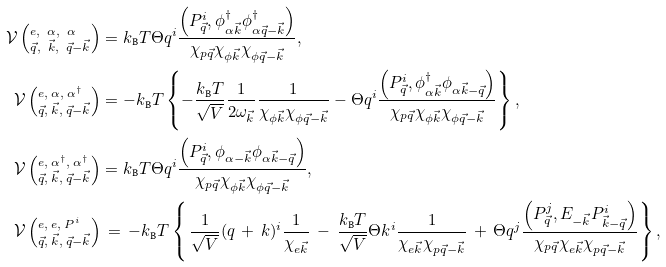<formula> <loc_0><loc_0><loc_500><loc_500>\mathcal { V } \left ( _ { \vec { q } , \ \vec { k } , \ \vec { q } - \vec { k } } ^ { e , \ \alpha , \ \alpha } \right ) & = k _ { \text  B}T \Theta q^{i} \frac{ \left(P_{\vec{q}} ^ { i } , \phi _ { \alpha \vec { k } } ^ { \dagger } \phi _ { \alpha \vec { q } - \vec { k } } ^ { \dagger } \right ) } { \chi _ { p \vec { q } } \chi _ { \phi \vec { k } } \chi _ { \phi \vec { q } - \vec { k } } } , \\ \mathcal { V } \left ( _ { \vec { q } , \ \vec { k } , \ \vec { q } - \vec { k } } ^ { e , \ \alpha , \ \alpha ^ { \dagger } } \right ) & = - k _ { \text  B}T \left\{ -\frac{k_{\text  B} T } { \sqrt { V } } \frac { 1 } { 2 \omega _ { \vec { k } } } \frac { 1 } { \chi _ { \phi \vec { k } } \chi _ { \phi \vec { q } - \vec { k } } } - \Theta q ^ { i } \frac { \left ( P _ { \vec { q } } ^ { i } , \phi _ { \alpha \vec { k } } ^ { \dagger } \phi _ { \alpha \vec { k } - \vec { q } } \right ) } { \chi _ { p \vec { q } } \chi _ { \phi \vec { k } } \chi _ { \phi \vec { q } - \vec { k } } } \right \} , \\ \mathcal { V } \left ( _ { \vec { q } , \ \vec { k } , \ \vec { q } - \vec { k } } ^ { e , \ \alpha ^ { \dagger } , \ \alpha ^ { \dagger } } \right ) & = k _ { \text  B}T \Theta q^{i} \frac{ \left(P_{\vec{q}} ^ { i } , \phi _ { \alpha - \vec { k } } \phi _ { \alpha \vec { k } - \vec { q } } \right ) } { \chi _ { p \vec { q } } \chi _ { \phi \vec { k } } \chi _ { \phi \vec { q } - \vec { k } } } , \\ \mathcal { V } \left ( _ { \vec { q } , \ \vec { k } , \ \vec { q } - \vec { k } } ^ { e , \ e , \ P ^ { i } } \right ) & \, = \, - k _ { \text  B}T \left\{\, \frac{1}{\sqrt{V} } ( q \, + \, k ) ^ { i } \frac { 1 } { \chi _ { e \vec { k } } } \, - \, \frac { k _ { \text  B}T}{\sqrt{V}} \Theta k^{i} \frac{1}{\chi_{e\vec{k} } \chi _ { p \vec { q } - \vec { k } } } \, + \, \Theta q ^ { j } \frac { \left ( P _ { \vec { q } } ^ { j } , E _ { - \vec { k } } P _ { \vec { k } - \vec { q } } ^ { i } \right ) } { \chi _ { p \vec { q } } \chi _ { e \vec { k } } \chi _ { p \vec { q } - \vec { k } } } \right \} ,</formula> 